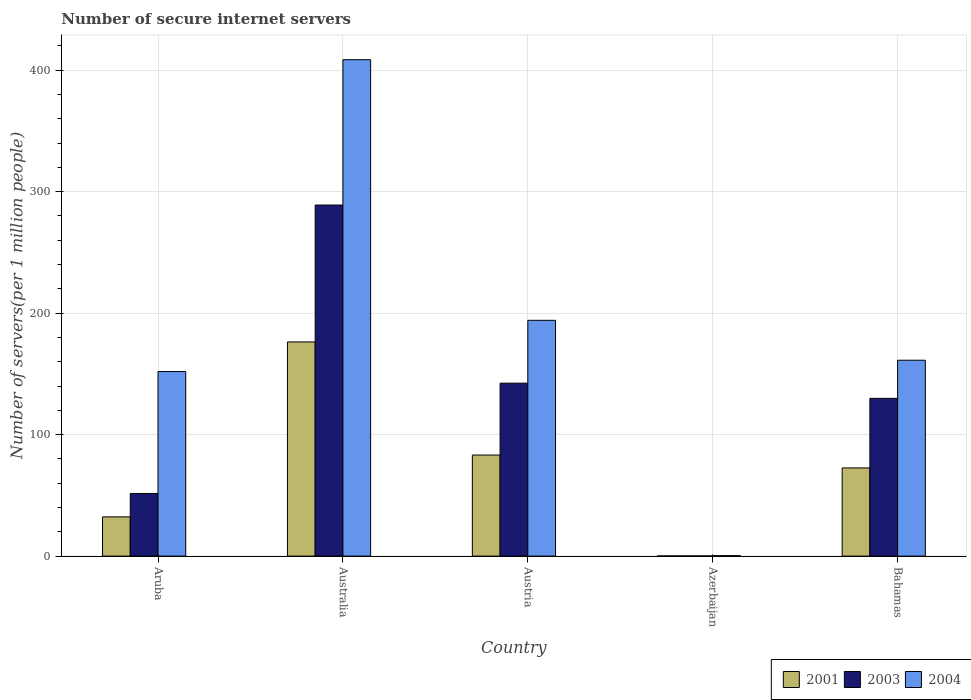How many different coloured bars are there?
Provide a short and direct response. 3. How many bars are there on the 2nd tick from the left?
Your response must be concise. 3. How many bars are there on the 2nd tick from the right?
Make the answer very short. 3. What is the label of the 2nd group of bars from the left?
Your answer should be very brief. Australia. In how many cases, is the number of bars for a given country not equal to the number of legend labels?
Make the answer very short. 0. What is the number of secure internet servers in 2003 in Australia?
Ensure brevity in your answer.  288.96. Across all countries, what is the maximum number of secure internet servers in 2001?
Offer a terse response. 176.27. Across all countries, what is the minimum number of secure internet servers in 2003?
Provide a short and direct response. 0.12. In which country was the number of secure internet servers in 2004 maximum?
Provide a short and direct response. Australia. In which country was the number of secure internet servers in 2004 minimum?
Offer a very short reply. Azerbaijan. What is the total number of secure internet servers in 2001 in the graph?
Provide a short and direct response. 364.45. What is the difference between the number of secure internet servers in 2003 in Australia and that in Bahamas?
Provide a short and direct response. 159.11. What is the difference between the number of secure internet servers in 2003 in Austria and the number of secure internet servers in 2004 in Aruba?
Ensure brevity in your answer.  -9.57. What is the average number of secure internet servers in 2003 per country?
Keep it short and to the point. 122.56. What is the difference between the number of secure internet servers of/in 2003 and number of secure internet servers of/in 2001 in Azerbaijan?
Give a very brief answer. -0. What is the ratio of the number of secure internet servers in 2001 in Azerbaijan to that in Bahamas?
Make the answer very short. 0. What is the difference between the highest and the second highest number of secure internet servers in 2001?
Your response must be concise. 103.7. What is the difference between the highest and the lowest number of secure internet servers in 2004?
Your answer should be very brief. 408.24. In how many countries, is the number of secure internet servers in 2001 greater than the average number of secure internet servers in 2001 taken over all countries?
Your response must be concise. 2. Is the sum of the number of secure internet servers in 2001 in Aruba and Azerbaijan greater than the maximum number of secure internet servers in 2004 across all countries?
Your answer should be compact. No. How many bars are there?
Offer a very short reply. 15. Are all the bars in the graph horizontal?
Your answer should be very brief. No. Does the graph contain any zero values?
Your response must be concise. No. Where does the legend appear in the graph?
Provide a short and direct response. Bottom right. What is the title of the graph?
Provide a succinct answer. Number of secure internet servers. What is the label or title of the Y-axis?
Make the answer very short. Number of servers(per 1 million people). What is the Number of servers(per 1 million people) in 2001 in Aruba?
Ensure brevity in your answer.  32.29. What is the Number of servers(per 1 million people) of 2003 in Aruba?
Ensure brevity in your answer.  51.54. What is the Number of servers(per 1 million people) in 2004 in Aruba?
Give a very brief answer. 151.91. What is the Number of servers(per 1 million people) in 2001 in Australia?
Your answer should be very brief. 176.27. What is the Number of servers(per 1 million people) of 2003 in Australia?
Your answer should be compact. 288.96. What is the Number of servers(per 1 million people) of 2004 in Australia?
Your answer should be compact. 408.6. What is the Number of servers(per 1 million people) of 2001 in Austria?
Offer a very short reply. 83.19. What is the Number of servers(per 1 million people) of 2003 in Austria?
Offer a very short reply. 142.34. What is the Number of servers(per 1 million people) in 2004 in Austria?
Give a very brief answer. 194.08. What is the Number of servers(per 1 million people) in 2001 in Azerbaijan?
Give a very brief answer. 0.12. What is the Number of servers(per 1 million people) of 2003 in Azerbaijan?
Provide a succinct answer. 0.12. What is the Number of servers(per 1 million people) in 2004 in Azerbaijan?
Keep it short and to the point. 0.36. What is the Number of servers(per 1 million people) in 2001 in Bahamas?
Offer a very short reply. 72.57. What is the Number of servers(per 1 million people) in 2003 in Bahamas?
Your response must be concise. 129.85. What is the Number of servers(per 1 million people) in 2004 in Bahamas?
Your answer should be very brief. 161.22. Across all countries, what is the maximum Number of servers(per 1 million people) in 2001?
Your answer should be compact. 176.27. Across all countries, what is the maximum Number of servers(per 1 million people) in 2003?
Give a very brief answer. 288.96. Across all countries, what is the maximum Number of servers(per 1 million people) in 2004?
Keep it short and to the point. 408.6. Across all countries, what is the minimum Number of servers(per 1 million people) in 2001?
Keep it short and to the point. 0.12. Across all countries, what is the minimum Number of servers(per 1 million people) in 2003?
Provide a short and direct response. 0.12. Across all countries, what is the minimum Number of servers(per 1 million people) in 2004?
Offer a terse response. 0.36. What is the total Number of servers(per 1 million people) of 2001 in the graph?
Ensure brevity in your answer.  364.45. What is the total Number of servers(per 1 million people) of 2003 in the graph?
Ensure brevity in your answer.  612.81. What is the total Number of servers(per 1 million people) in 2004 in the graph?
Your response must be concise. 916.17. What is the difference between the Number of servers(per 1 million people) of 2001 in Aruba and that in Australia?
Give a very brief answer. -143.98. What is the difference between the Number of servers(per 1 million people) in 2003 in Aruba and that in Australia?
Provide a short and direct response. -237.42. What is the difference between the Number of servers(per 1 million people) of 2004 in Aruba and that in Australia?
Offer a terse response. -256.69. What is the difference between the Number of servers(per 1 million people) in 2001 in Aruba and that in Austria?
Ensure brevity in your answer.  -50.89. What is the difference between the Number of servers(per 1 million people) of 2003 in Aruba and that in Austria?
Offer a terse response. -90.8. What is the difference between the Number of servers(per 1 million people) in 2004 in Aruba and that in Austria?
Give a very brief answer. -42.17. What is the difference between the Number of servers(per 1 million people) in 2001 in Aruba and that in Azerbaijan?
Your response must be concise. 32.17. What is the difference between the Number of servers(per 1 million people) of 2003 in Aruba and that in Azerbaijan?
Offer a very short reply. 51.42. What is the difference between the Number of servers(per 1 million people) in 2004 in Aruba and that in Azerbaijan?
Provide a short and direct response. 151.55. What is the difference between the Number of servers(per 1 million people) in 2001 in Aruba and that in Bahamas?
Give a very brief answer. -40.28. What is the difference between the Number of servers(per 1 million people) in 2003 in Aruba and that in Bahamas?
Your answer should be very brief. -78.31. What is the difference between the Number of servers(per 1 million people) of 2004 in Aruba and that in Bahamas?
Offer a very short reply. -9.31. What is the difference between the Number of servers(per 1 million people) in 2001 in Australia and that in Austria?
Make the answer very short. 93.09. What is the difference between the Number of servers(per 1 million people) of 2003 in Australia and that in Austria?
Provide a short and direct response. 146.62. What is the difference between the Number of servers(per 1 million people) of 2004 in Australia and that in Austria?
Your answer should be very brief. 214.52. What is the difference between the Number of servers(per 1 million people) of 2001 in Australia and that in Azerbaijan?
Give a very brief answer. 176.15. What is the difference between the Number of servers(per 1 million people) in 2003 in Australia and that in Azerbaijan?
Ensure brevity in your answer.  288.84. What is the difference between the Number of servers(per 1 million people) in 2004 in Australia and that in Azerbaijan?
Ensure brevity in your answer.  408.24. What is the difference between the Number of servers(per 1 million people) in 2001 in Australia and that in Bahamas?
Give a very brief answer. 103.7. What is the difference between the Number of servers(per 1 million people) of 2003 in Australia and that in Bahamas?
Offer a terse response. 159.11. What is the difference between the Number of servers(per 1 million people) in 2004 in Australia and that in Bahamas?
Offer a terse response. 247.38. What is the difference between the Number of servers(per 1 million people) in 2001 in Austria and that in Azerbaijan?
Make the answer very short. 83.06. What is the difference between the Number of servers(per 1 million people) in 2003 in Austria and that in Azerbaijan?
Make the answer very short. 142.22. What is the difference between the Number of servers(per 1 million people) in 2004 in Austria and that in Azerbaijan?
Give a very brief answer. 193.72. What is the difference between the Number of servers(per 1 million people) in 2001 in Austria and that in Bahamas?
Your answer should be compact. 10.61. What is the difference between the Number of servers(per 1 million people) of 2003 in Austria and that in Bahamas?
Your answer should be compact. 12.49. What is the difference between the Number of servers(per 1 million people) in 2004 in Austria and that in Bahamas?
Ensure brevity in your answer.  32.86. What is the difference between the Number of servers(per 1 million people) in 2001 in Azerbaijan and that in Bahamas?
Your answer should be compact. -72.45. What is the difference between the Number of servers(per 1 million people) in 2003 in Azerbaijan and that in Bahamas?
Your answer should be very brief. -129.73. What is the difference between the Number of servers(per 1 million people) of 2004 in Azerbaijan and that in Bahamas?
Give a very brief answer. -160.86. What is the difference between the Number of servers(per 1 million people) in 2001 in Aruba and the Number of servers(per 1 million people) in 2003 in Australia?
Your answer should be compact. -256.67. What is the difference between the Number of servers(per 1 million people) of 2001 in Aruba and the Number of servers(per 1 million people) of 2004 in Australia?
Your answer should be compact. -376.3. What is the difference between the Number of servers(per 1 million people) in 2003 in Aruba and the Number of servers(per 1 million people) in 2004 in Australia?
Give a very brief answer. -357.06. What is the difference between the Number of servers(per 1 million people) of 2001 in Aruba and the Number of servers(per 1 million people) of 2003 in Austria?
Your response must be concise. -110.04. What is the difference between the Number of servers(per 1 million people) in 2001 in Aruba and the Number of servers(per 1 million people) in 2004 in Austria?
Make the answer very short. -161.78. What is the difference between the Number of servers(per 1 million people) of 2003 in Aruba and the Number of servers(per 1 million people) of 2004 in Austria?
Your answer should be compact. -142.54. What is the difference between the Number of servers(per 1 million people) of 2001 in Aruba and the Number of servers(per 1 million people) of 2003 in Azerbaijan?
Offer a very short reply. 32.17. What is the difference between the Number of servers(per 1 million people) of 2001 in Aruba and the Number of servers(per 1 million people) of 2004 in Azerbaijan?
Provide a short and direct response. 31.93. What is the difference between the Number of servers(per 1 million people) in 2003 in Aruba and the Number of servers(per 1 million people) in 2004 in Azerbaijan?
Make the answer very short. 51.18. What is the difference between the Number of servers(per 1 million people) in 2001 in Aruba and the Number of servers(per 1 million people) in 2003 in Bahamas?
Offer a terse response. -97.55. What is the difference between the Number of servers(per 1 million people) of 2001 in Aruba and the Number of servers(per 1 million people) of 2004 in Bahamas?
Ensure brevity in your answer.  -128.93. What is the difference between the Number of servers(per 1 million people) of 2003 in Aruba and the Number of servers(per 1 million people) of 2004 in Bahamas?
Give a very brief answer. -109.68. What is the difference between the Number of servers(per 1 million people) in 2001 in Australia and the Number of servers(per 1 million people) in 2003 in Austria?
Your response must be concise. 33.93. What is the difference between the Number of servers(per 1 million people) in 2001 in Australia and the Number of servers(per 1 million people) in 2004 in Austria?
Your answer should be compact. -17.8. What is the difference between the Number of servers(per 1 million people) in 2003 in Australia and the Number of servers(per 1 million people) in 2004 in Austria?
Ensure brevity in your answer.  94.88. What is the difference between the Number of servers(per 1 million people) of 2001 in Australia and the Number of servers(per 1 million people) of 2003 in Azerbaijan?
Your answer should be very brief. 176.15. What is the difference between the Number of servers(per 1 million people) of 2001 in Australia and the Number of servers(per 1 million people) of 2004 in Azerbaijan?
Ensure brevity in your answer.  175.91. What is the difference between the Number of servers(per 1 million people) of 2003 in Australia and the Number of servers(per 1 million people) of 2004 in Azerbaijan?
Your answer should be very brief. 288.6. What is the difference between the Number of servers(per 1 million people) in 2001 in Australia and the Number of servers(per 1 million people) in 2003 in Bahamas?
Ensure brevity in your answer.  46.43. What is the difference between the Number of servers(per 1 million people) of 2001 in Australia and the Number of servers(per 1 million people) of 2004 in Bahamas?
Your answer should be very brief. 15.05. What is the difference between the Number of servers(per 1 million people) in 2003 in Australia and the Number of servers(per 1 million people) in 2004 in Bahamas?
Ensure brevity in your answer.  127.74. What is the difference between the Number of servers(per 1 million people) in 2001 in Austria and the Number of servers(per 1 million people) in 2003 in Azerbaijan?
Your answer should be very brief. 83.06. What is the difference between the Number of servers(per 1 million people) in 2001 in Austria and the Number of servers(per 1 million people) in 2004 in Azerbaijan?
Make the answer very short. 82.82. What is the difference between the Number of servers(per 1 million people) in 2003 in Austria and the Number of servers(per 1 million people) in 2004 in Azerbaijan?
Your answer should be very brief. 141.98. What is the difference between the Number of servers(per 1 million people) in 2001 in Austria and the Number of servers(per 1 million people) in 2003 in Bahamas?
Offer a terse response. -46.66. What is the difference between the Number of servers(per 1 million people) in 2001 in Austria and the Number of servers(per 1 million people) in 2004 in Bahamas?
Provide a short and direct response. -78.04. What is the difference between the Number of servers(per 1 million people) in 2003 in Austria and the Number of servers(per 1 million people) in 2004 in Bahamas?
Offer a terse response. -18.88. What is the difference between the Number of servers(per 1 million people) of 2001 in Azerbaijan and the Number of servers(per 1 million people) of 2003 in Bahamas?
Your response must be concise. -129.72. What is the difference between the Number of servers(per 1 million people) of 2001 in Azerbaijan and the Number of servers(per 1 million people) of 2004 in Bahamas?
Ensure brevity in your answer.  -161.1. What is the difference between the Number of servers(per 1 million people) in 2003 in Azerbaijan and the Number of servers(per 1 million people) in 2004 in Bahamas?
Your answer should be very brief. -161.1. What is the average Number of servers(per 1 million people) of 2001 per country?
Your response must be concise. 72.89. What is the average Number of servers(per 1 million people) of 2003 per country?
Your answer should be very brief. 122.56. What is the average Number of servers(per 1 million people) in 2004 per country?
Keep it short and to the point. 183.23. What is the difference between the Number of servers(per 1 million people) in 2001 and Number of servers(per 1 million people) in 2003 in Aruba?
Your response must be concise. -19.24. What is the difference between the Number of servers(per 1 million people) in 2001 and Number of servers(per 1 million people) in 2004 in Aruba?
Your answer should be very brief. -119.62. What is the difference between the Number of servers(per 1 million people) of 2003 and Number of servers(per 1 million people) of 2004 in Aruba?
Ensure brevity in your answer.  -100.37. What is the difference between the Number of servers(per 1 million people) of 2001 and Number of servers(per 1 million people) of 2003 in Australia?
Your answer should be very brief. -112.69. What is the difference between the Number of servers(per 1 million people) in 2001 and Number of servers(per 1 million people) in 2004 in Australia?
Keep it short and to the point. -232.32. What is the difference between the Number of servers(per 1 million people) of 2003 and Number of servers(per 1 million people) of 2004 in Australia?
Provide a succinct answer. -119.64. What is the difference between the Number of servers(per 1 million people) in 2001 and Number of servers(per 1 million people) in 2003 in Austria?
Provide a succinct answer. -59.15. What is the difference between the Number of servers(per 1 million people) in 2001 and Number of servers(per 1 million people) in 2004 in Austria?
Your answer should be very brief. -110.89. What is the difference between the Number of servers(per 1 million people) in 2003 and Number of servers(per 1 million people) in 2004 in Austria?
Your answer should be compact. -51.74. What is the difference between the Number of servers(per 1 million people) of 2001 and Number of servers(per 1 million people) of 2003 in Azerbaijan?
Your answer should be very brief. 0. What is the difference between the Number of servers(per 1 million people) in 2001 and Number of servers(per 1 million people) in 2004 in Azerbaijan?
Ensure brevity in your answer.  -0.24. What is the difference between the Number of servers(per 1 million people) in 2003 and Number of servers(per 1 million people) in 2004 in Azerbaijan?
Ensure brevity in your answer.  -0.24. What is the difference between the Number of servers(per 1 million people) in 2001 and Number of servers(per 1 million people) in 2003 in Bahamas?
Your answer should be compact. -57.27. What is the difference between the Number of servers(per 1 million people) in 2001 and Number of servers(per 1 million people) in 2004 in Bahamas?
Your answer should be very brief. -88.65. What is the difference between the Number of servers(per 1 million people) in 2003 and Number of servers(per 1 million people) in 2004 in Bahamas?
Give a very brief answer. -31.37. What is the ratio of the Number of servers(per 1 million people) of 2001 in Aruba to that in Australia?
Your response must be concise. 0.18. What is the ratio of the Number of servers(per 1 million people) in 2003 in Aruba to that in Australia?
Make the answer very short. 0.18. What is the ratio of the Number of servers(per 1 million people) in 2004 in Aruba to that in Australia?
Give a very brief answer. 0.37. What is the ratio of the Number of servers(per 1 million people) of 2001 in Aruba to that in Austria?
Your answer should be compact. 0.39. What is the ratio of the Number of servers(per 1 million people) of 2003 in Aruba to that in Austria?
Ensure brevity in your answer.  0.36. What is the ratio of the Number of servers(per 1 million people) of 2004 in Aruba to that in Austria?
Give a very brief answer. 0.78. What is the ratio of the Number of servers(per 1 million people) in 2001 in Aruba to that in Azerbaijan?
Give a very brief answer. 261.95. What is the ratio of the Number of servers(per 1 million people) of 2003 in Aruba to that in Azerbaijan?
Your answer should be compact. 424.37. What is the ratio of the Number of servers(per 1 million people) in 2004 in Aruba to that in Azerbaijan?
Your response must be concise. 420.62. What is the ratio of the Number of servers(per 1 million people) in 2001 in Aruba to that in Bahamas?
Provide a short and direct response. 0.45. What is the ratio of the Number of servers(per 1 million people) in 2003 in Aruba to that in Bahamas?
Provide a succinct answer. 0.4. What is the ratio of the Number of servers(per 1 million people) in 2004 in Aruba to that in Bahamas?
Provide a short and direct response. 0.94. What is the ratio of the Number of servers(per 1 million people) in 2001 in Australia to that in Austria?
Your response must be concise. 2.12. What is the ratio of the Number of servers(per 1 million people) of 2003 in Australia to that in Austria?
Make the answer very short. 2.03. What is the ratio of the Number of servers(per 1 million people) of 2004 in Australia to that in Austria?
Your answer should be compact. 2.11. What is the ratio of the Number of servers(per 1 million people) in 2001 in Australia to that in Azerbaijan?
Your answer should be compact. 1429.79. What is the ratio of the Number of servers(per 1 million people) of 2003 in Australia to that in Azerbaijan?
Give a very brief answer. 2379.34. What is the ratio of the Number of servers(per 1 million people) of 2004 in Australia to that in Azerbaijan?
Provide a succinct answer. 1131.34. What is the ratio of the Number of servers(per 1 million people) in 2001 in Australia to that in Bahamas?
Keep it short and to the point. 2.43. What is the ratio of the Number of servers(per 1 million people) in 2003 in Australia to that in Bahamas?
Your response must be concise. 2.23. What is the ratio of the Number of servers(per 1 million people) in 2004 in Australia to that in Bahamas?
Give a very brief answer. 2.53. What is the ratio of the Number of servers(per 1 million people) of 2001 in Austria to that in Azerbaijan?
Your response must be concise. 674.73. What is the ratio of the Number of servers(per 1 million people) in 2003 in Austria to that in Azerbaijan?
Offer a very short reply. 1172.04. What is the ratio of the Number of servers(per 1 million people) of 2004 in Austria to that in Azerbaijan?
Your answer should be very brief. 537.37. What is the ratio of the Number of servers(per 1 million people) in 2001 in Austria to that in Bahamas?
Your answer should be compact. 1.15. What is the ratio of the Number of servers(per 1 million people) in 2003 in Austria to that in Bahamas?
Give a very brief answer. 1.1. What is the ratio of the Number of servers(per 1 million people) of 2004 in Austria to that in Bahamas?
Your response must be concise. 1.2. What is the ratio of the Number of servers(per 1 million people) in 2001 in Azerbaijan to that in Bahamas?
Offer a very short reply. 0. What is the ratio of the Number of servers(per 1 million people) of 2003 in Azerbaijan to that in Bahamas?
Provide a succinct answer. 0. What is the ratio of the Number of servers(per 1 million people) in 2004 in Azerbaijan to that in Bahamas?
Ensure brevity in your answer.  0. What is the difference between the highest and the second highest Number of servers(per 1 million people) of 2001?
Keep it short and to the point. 93.09. What is the difference between the highest and the second highest Number of servers(per 1 million people) in 2003?
Your response must be concise. 146.62. What is the difference between the highest and the second highest Number of servers(per 1 million people) of 2004?
Give a very brief answer. 214.52. What is the difference between the highest and the lowest Number of servers(per 1 million people) in 2001?
Your answer should be compact. 176.15. What is the difference between the highest and the lowest Number of servers(per 1 million people) of 2003?
Provide a succinct answer. 288.84. What is the difference between the highest and the lowest Number of servers(per 1 million people) of 2004?
Provide a succinct answer. 408.24. 